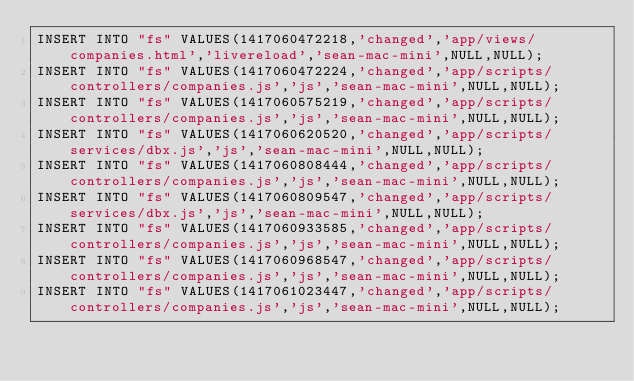<code> <loc_0><loc_0><loc_500><loc_500><_SQL_>INSERT INTO "fs" VALUES(1417060472218,'changed','app/views/companies.html','livereload','sean-mac-mini',NULL,NULL);
INSERT INTO "fs" VALUES(1417060472224,'changed','app/scripts/controllers/companies.js','js','sean-mac-mini',NULL,NULL);
INSERT INTO "fs" VALUES(1417060575219,'changed','app/scripts/controllers/companies.js','js','sean-mac-mini',NULL,NULL);
INSERT INTO "fs" VALUES(1417060620520,'changed','app/scripts/services/dbx.js','js','sean-mac-mini',NULL,NULL);
INSERT INTO "fs" VALUES(1417060808444,'changed','app/scripts/controllers/companies.js','js','sean-mac-mini',NULL,NULL);
INSERT INTO "fs" VALUES(1417060809547,'changed','app/scripts/services/dbx.js','js','sean-mac-mini',NULL,NULL);
INSERT INTO "fs" VALUES(1417060933585,'changed','app/scripts/controllers/companies.js','js','sean-mac-mini',NULL,NULL);
INSERT INTO "fs" VALUES(1417060968547,'changed','app/scripts/controllers/companies.js','js','sean-mac-mini',NULL,NULL);
INSERT INTO "fs" VALUES(1417061023447,'changed','app/scripts/controllers/companies.js','js','sean-mac-mini',NULL,NULL);</code> 